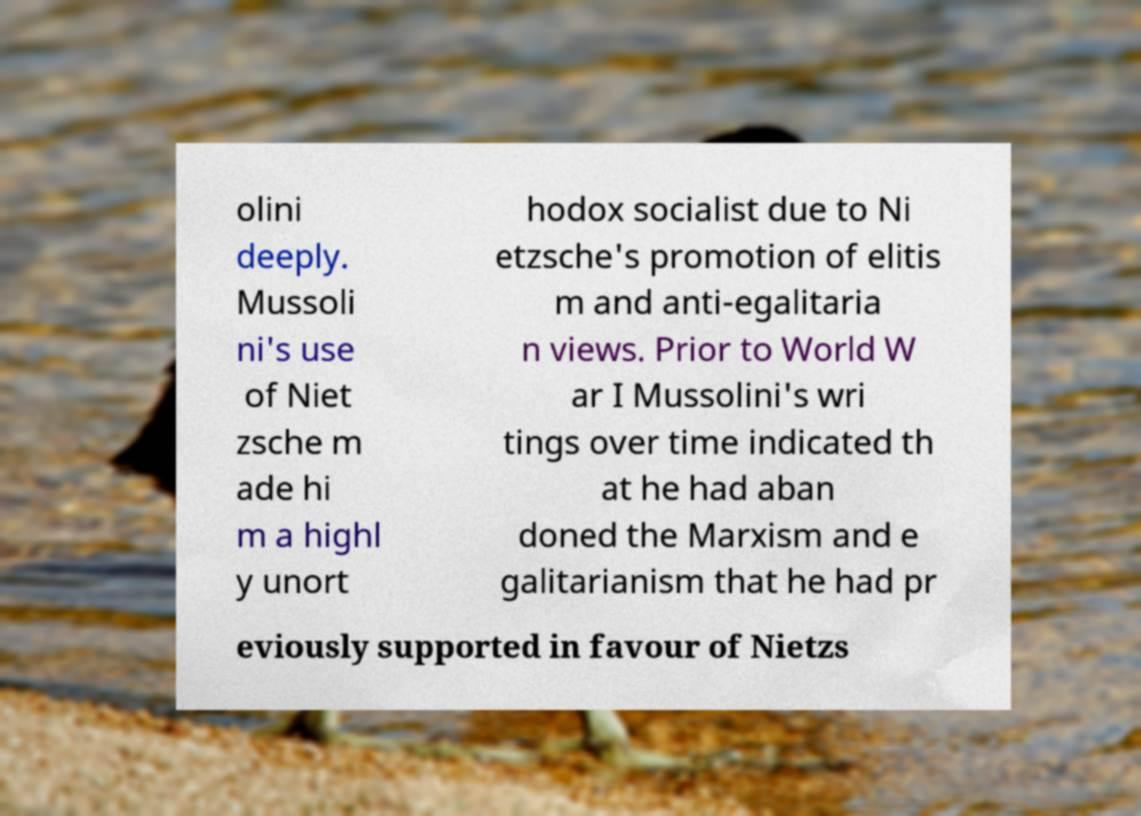Please read and relay the text visible in this image. What does it say? olini deeply. Mussoli ni's use of Niet zsche m ade hi m a highl y unort hodox socialist due to Ni etzsche's promotion of elitis m and anti-egalitaria n views. Prior to World W ar I Mussolini's wri tings over time indicated th at he had aban doned the Marxism and e galitarianism that he had pr eviously supported in favour of Nietzs 